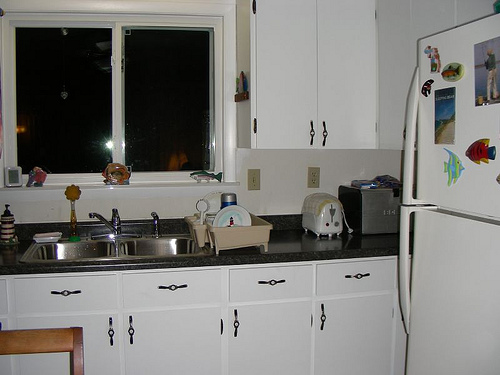<image>Are there any plants on the sink? There are no plants on the sink. Are there any plants on the sink? There are no plants on the sink. 